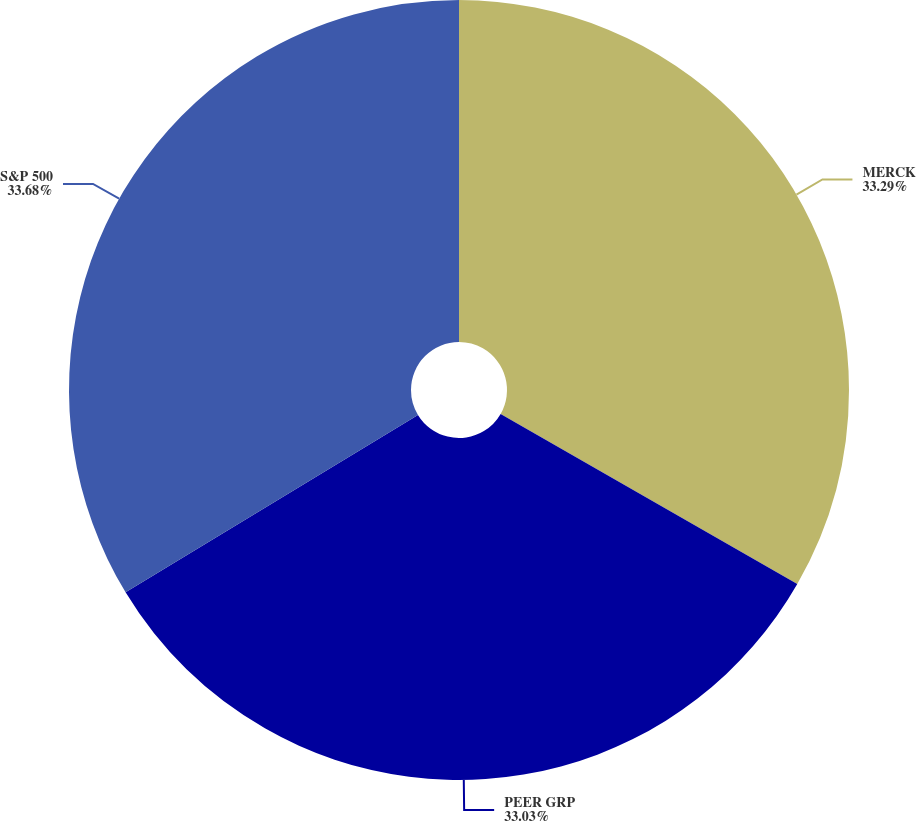Convert chart. <chart><loc_0><loc_0><loc_500><loc_500><pie_chart><fcel>MERCK<fcel>PEER GRP<fcel>S&P 500<nl><fcel>33.29%<fcel>33.03%<fcel>33.68%<nl></chart> 